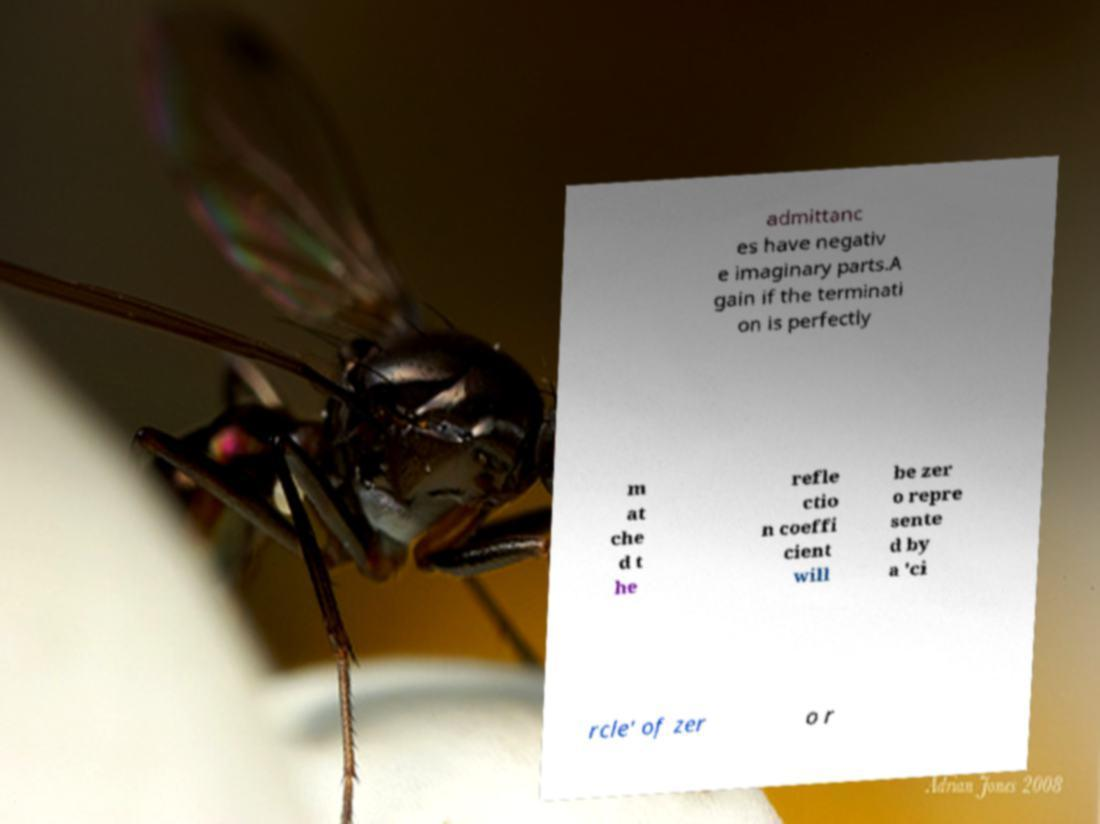Can you read and provide the text displayed in the image?This photo seems to have some interesting text. Can you extract and type it out for me? admittanc es have negativ e imaginary parts.A gain if the terminati on is perfectly m at che d t he refle ctio n coeffi cient will be zer o repre sente d by a 'ci rcle' of zer o r 